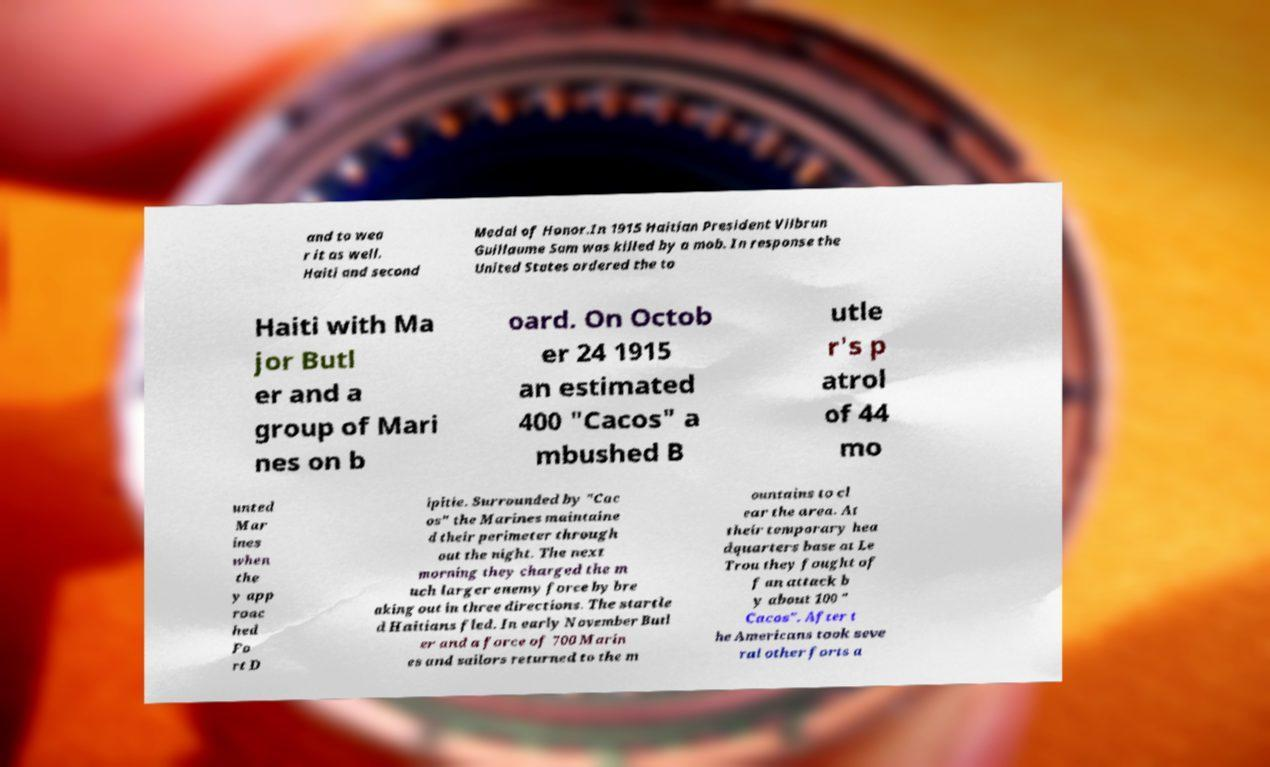Can you read and provide the text displayed in the image?This photo seems to have some interesting text. Can you extract and type it out for me? and to wea r it as well. Haiti and second Medal of Honor.In 1915 Haitian President Vilbrun Guillaume Sam was killed by a mob. In response the United States ordered the to Haiti with Ma jor Butl er and a group of Mari nes on b oard. On Octob er 24 1915 an estimated 400 "Cacos" a mbushed B utle r's p atrol of 44 mo unted Mar ines when the y app roac hed Fo rt D ipitie. Surrounded by "Cac os" the Marines maintaine d their perimeter through out the night. The next morning they charged the m uch larger enemy force by bre aking out in three directions. The startle d Haitians fled. In early November Butl er and a force of 700 Marin es and sailors returned to the m ountains to cl ear the area. At their temporary hea dquarters base at Le Trou they fought of f an attack b y about 100 " Cacos". After t he Americans took seve ral other forts a 